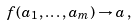<formula> <loc_0><loc_0><loc_500><loc_500>f ( a _ { 1 } , \dots , a _ { m } ) \rightarrow a \, ,</formula> 